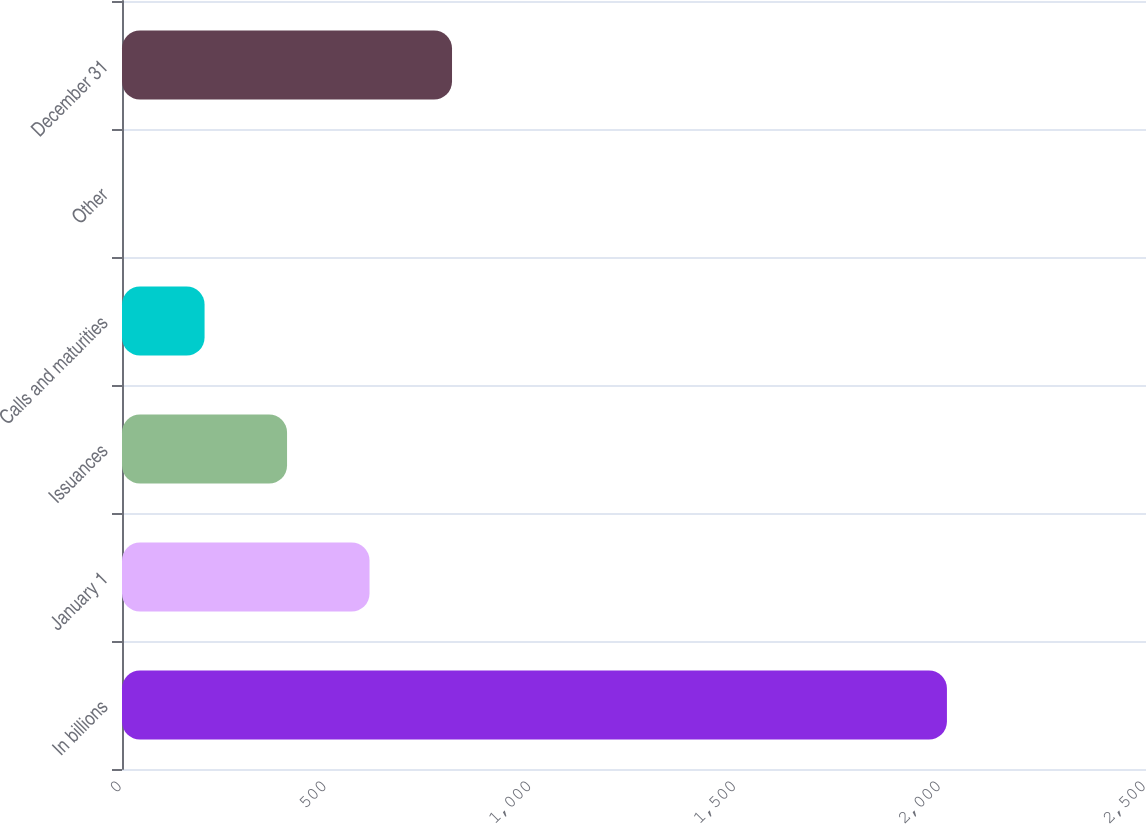<chart> <loc_0><loc_0><loc_500><loc_500><bar_chart><fcel>In billions<fcel>January 1<fcel>Issuances<fcel>Calls and maturities<fcel>Other<fcel>December 31<nl><fcel>2014<fcel>604.34<fcel>402.96<fcel>201.58<fcel>0.2<fcel>805.72<nl></chart> 